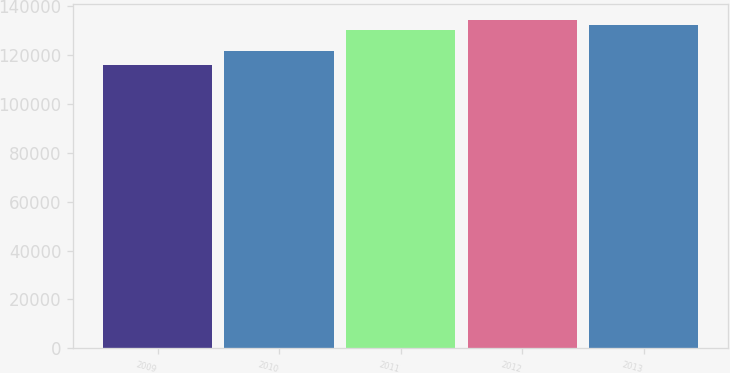Convert chart to OTSL. <chart><loc_0><loc_0><loc_500><loc_500><bar_chart><fcel>2009<fcel>2010<fcel>2011<fcel>2012<fcel>2013<nl><fcel>116028<fcel>121746<fcel>130394<fcel>134248<fcel>132216<nl></chart> 